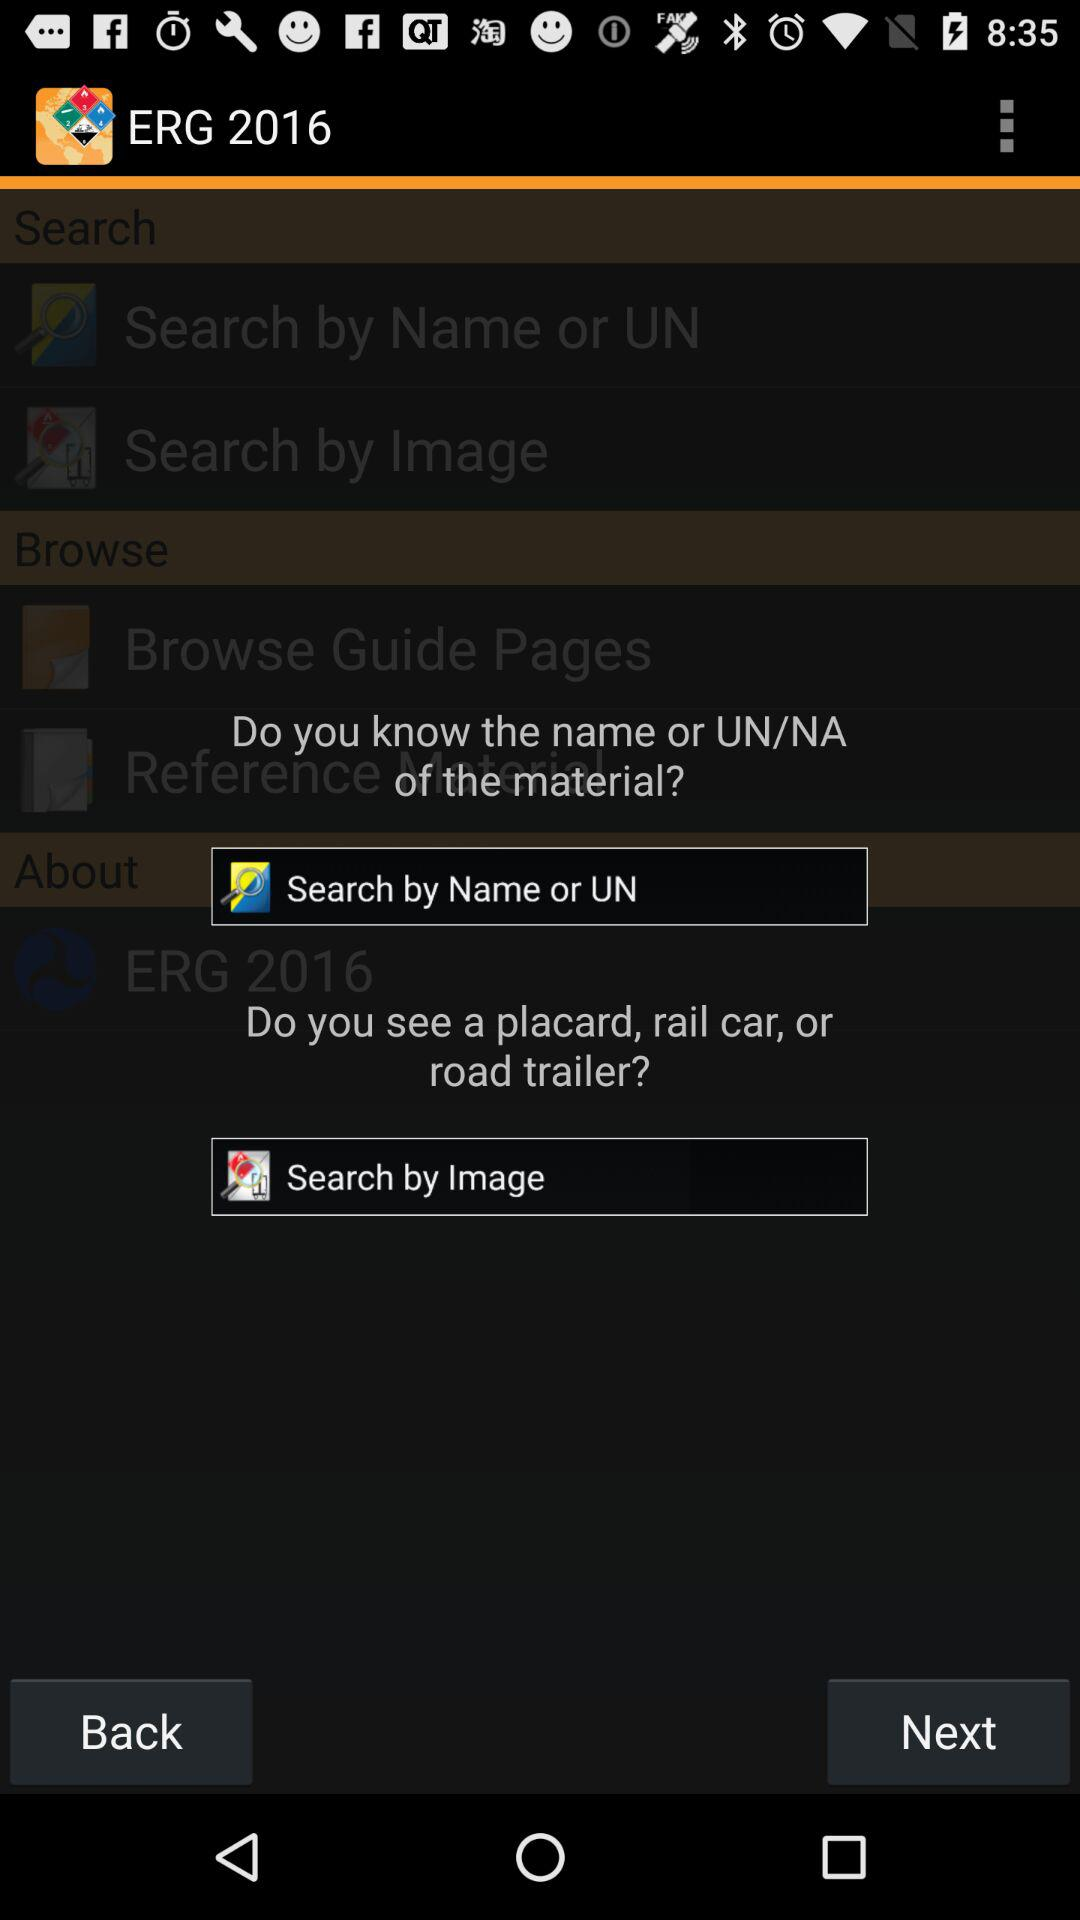What is the application name? The application name is "ERG 2016". 